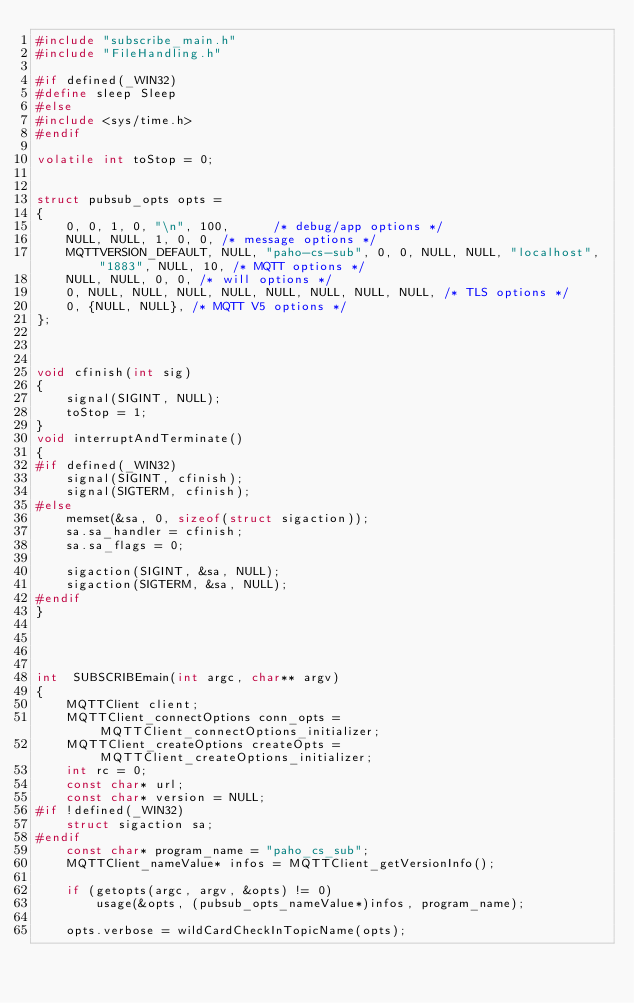Convert code to text. <code><loc_0><loc_0><loc_500><loc_500><_C_>#include "subscribe_main.h"
#include "FileHandling.h"

#if defined(_WIN32)
#define sleep Sleep
#else
#include <sys/time.h>
#endif

volatile int toStop = 0;


struct pubsub_opts opts =
{
	0, 0, 1, 0, "\n", 100,  	/* debug/app options */
	NULL, NULL, 1, 0, 0, /* message options */
	MQTTVERSION_DEFAULT, NULL, "paho-cs-sub", 0, 0, NULL, NULL, "localhost", "1883", NULL, 10, /* MQTT options */
	NULL, NULL, 0, 0, /* will options */
	0, NULL, NULL, NULL, NULL, NULL, NULL, NULL, NULL, /* TLS options */
	0, {NULL, NULL}, /* MQTT V5 options */
};



void cfinish(int sig)
{
	signal(SIGINT, NULL);
	toStop = 1;
}
void interruptAndTerminate()
{
#if defined(_WIN32)
	signal(SIGINT, cfinish);
	signal(SIGTERM, cfinish);
#else
	memset(&sa, 0, sizeof(struct sigaction));
	sa.sa_handler = cfinish;
	sa.sa_flags = 0;

	sigaction(SIGINT, &sa, NULL);
	sigaction(SIGTERM, &sa, NULL);
#endif
}




int  SUBSCRIBEmain(int argc, char** argv)
{
	MQTTClient client;
	MQTTClient_connectOptions conn_opts = MQTTClient_connectOptions_initializer;
	MQTTClient_createOptions createOpts = MQTTClient_createOptions_initializer;
	int rc = 0;
	const char* url;
	const char* version = NULL;
#if !defined(_WIN32)
	struct sigaction sa;
#endif
	const char* program_name = "paho_cs_sub";
	MQTTClient_nameValue* infos = MQTTClient_getVersionInfo();
	
	if (getopts(argc, argv, &opts) != 0)
		usage(&opts, (pubsub_opts_nameValue*)infos, program_name);

	opts.verbose = wildCardCheckInTopicName(opts);	
</code> 